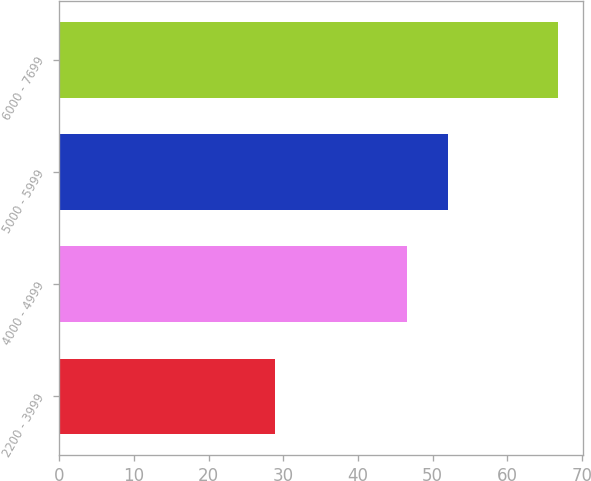Convert chart to OTSL. <chart><loc_0><loc_0><loc_500><loc_500><bar_chart><fcel>2200 - 3999<fcel>4000 - 4999<fcel>5000 - 5999<fcel>6000 - 7699<nl><fcel>28.94<fcel>46.51<fcel>52.08<fcel>66.75<nl></chart> 